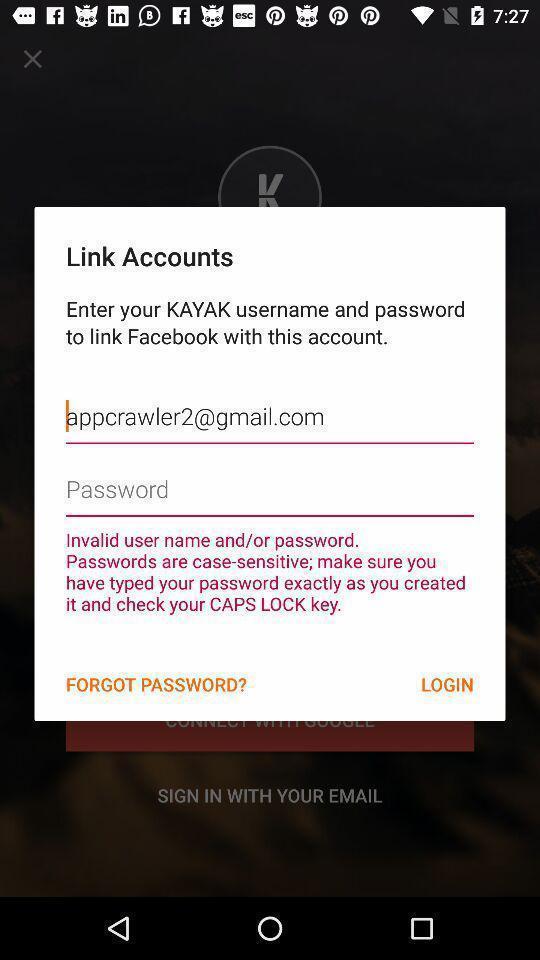Describe this image in words. Popup displaying signing in about account linking. 